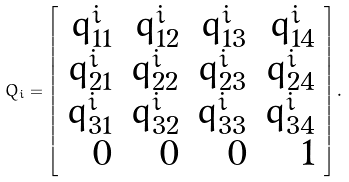<formula> <loc_0><loc_0><loc_500><loc_500>Q _ { i } = \left [ \begin{array} { r r r r } q _ { 1 1 } ^ { i } & q _ { 1 2 } ^ { i } & q _ { 1 3 } ^ { i } & q _ { 1 4 } ^ { i } \\ q _ { 2 1 } ^ { i } & q _ { 2 2 } ^ { i } & q _ { 2 3 } ^ { i } & q _ { 2 4 } ^ { i } \\ q _ { 3 1 } ^ { i } & q _ { 3 2 } ^ { i } & q _ { 3 3 } ^ { i } & q _ { 3 4 } ^ { i } \\ 0 & 0 & 0 & 1 \end{array} \right ] .</formula> 